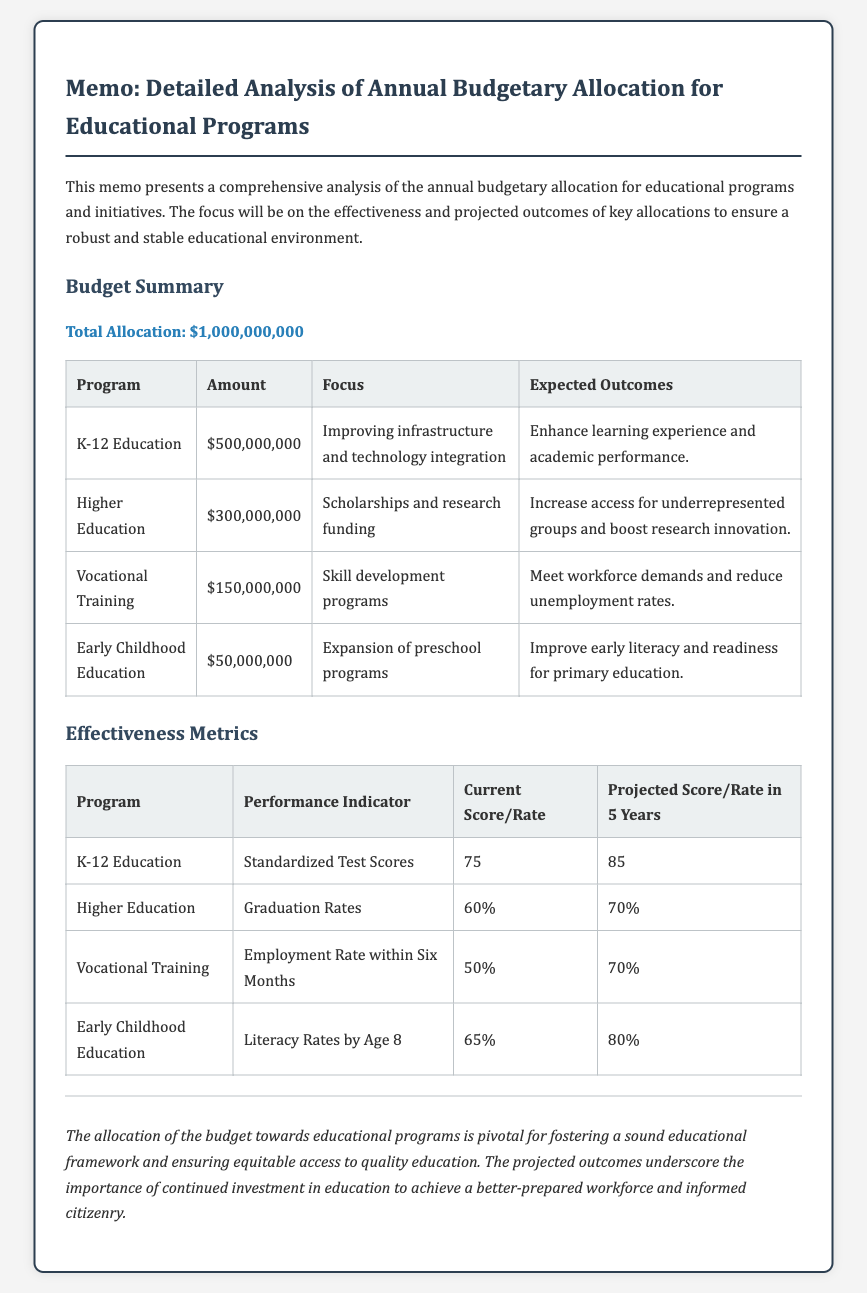What is the total allocation for educational programs? The total allocation is specified in the memo as the overall amount dedicated to educational programs and initiatives.
Answer: $1,000,000,000 How much is allocated to K-12 Education? The amount allocated to K-12 Education is mentioned in the budget summary table.
Answer: $500,000,000 What is the expected outcome for Vocational Training? The expected outcome for Vocational Training is provided in the context of the program's goals outlined in the budget section.
Answer: Meet workforce demands and reduce unemployment rates What is the current score for Standardized Test Scores in K-12 Education? The current score for Standardized Test Scores is listed in the effectiveness metrics table for K-12 Education.
Answer: 75 What will the graduation rate project for Higher Education in five years? The projected graduation rate is a key performance indicator for Higher Education, cited in the effectiveness metrics table.
Answer: 70% What program has the least amount of budget allocation? The budget allocation amounts are compared to identify which program receives the lowest funding according to the budget summary.
Answer: Early Childhood Education Which performance indicator is used for Vocational Training? The document includes specific indicators for assessing each program, and the one for Vocational Training is noted in the effectiveness metrics section.
Answer: Employment Rate within Six Months What is the final tone of the memo? The conclusion summarizes the overall impact of the budget and is articulated at the end of the memo, indicating its importance.
Answer: Pivotal for fostering a sound educational framework What is the projected literacy rate by age 8 for Early Childhood Education? The projected literacy rate is stated as a key outcome in the effectiveness metrics table for the Early Childhood Education program.
Answer: 80% 